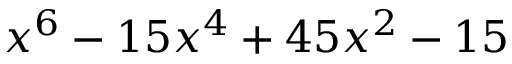<formula> <loc_0><loc_0><loc_500><loc_500>x ^ { 6 } - 1 5 x ^ { 4 } + 4 5 x ^ { 2 } - 1 5</formula> 